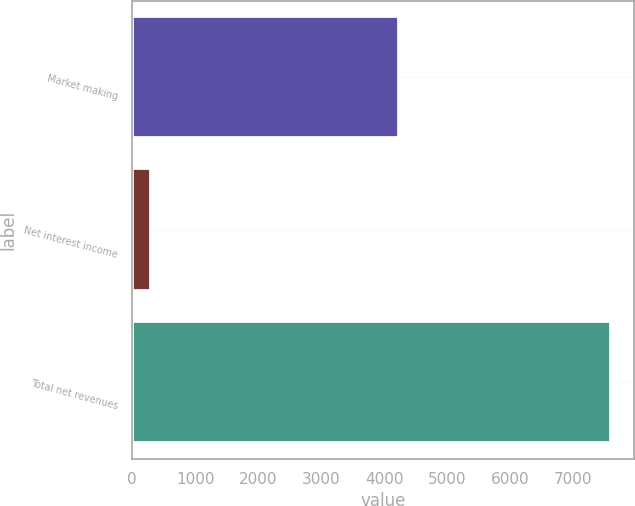<chart> <loc_0><loc_0><loc_500><loc_500><bar_chart><fcel>Market making<fcel>Net interest income<fcel>Total net revenues<nl><fcel>4240<fcel>305<fcel>7600<nl></chart> 